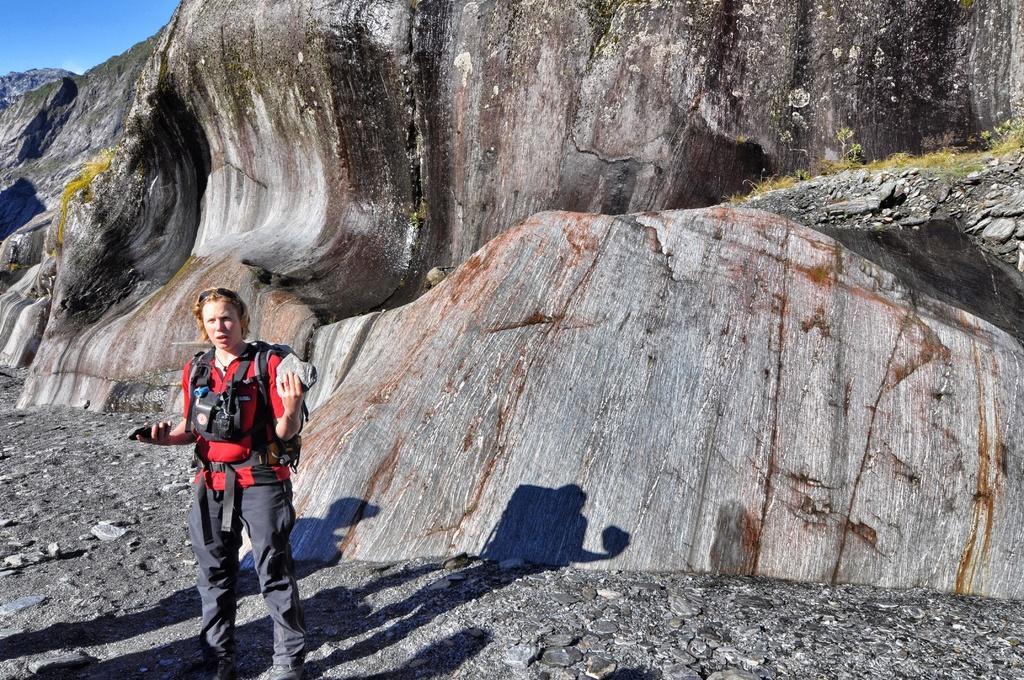In one or two sentences, can you explain what this image depicts? In this picture there is a girl on the left side of the image and there are rocks in the background area of the image. 